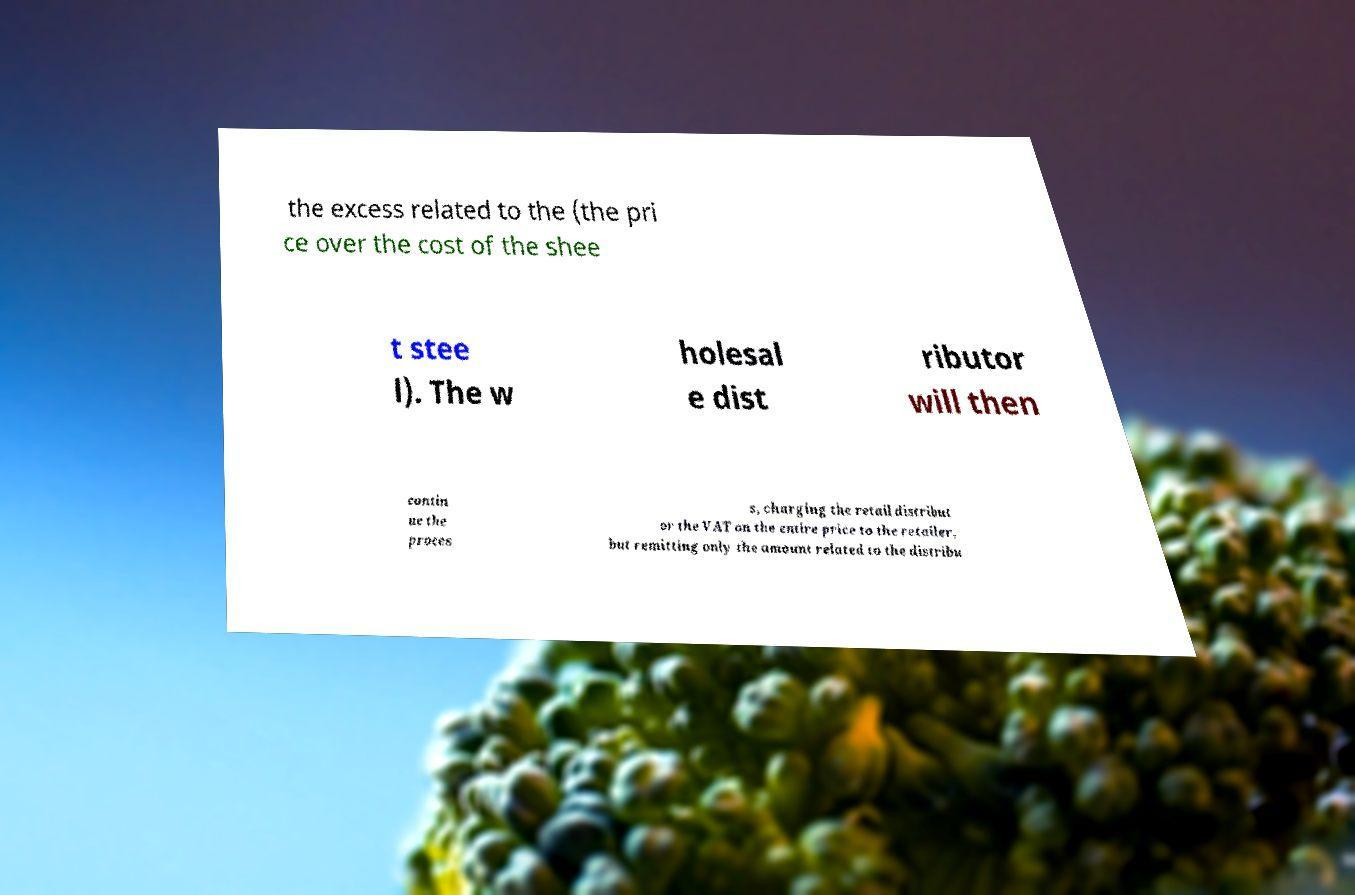For documentation purposes, I need the text within this image transcribed. Could you provide that? the excess related to the (the pri ce over the cost of the shee t stee l). The w holesal e dist ributor will then contin ue the proces s, charging the retail distribut or the VAT on the entire price to the retailer, but remitting only the amount related to the distribu 